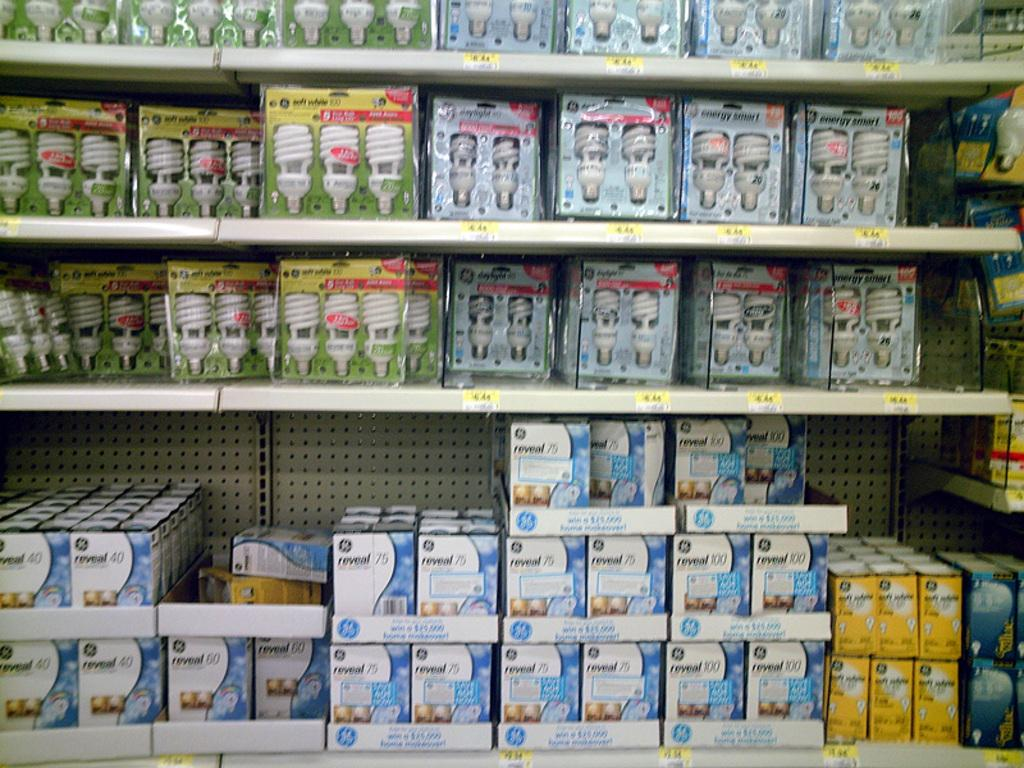What objects are present in the image? There are bulbs in the image. Where are the bulbs located? The bulbs are placed on shelves. What type of cheese is being stored on the shelves in the image? There is no cheese present in the image; it features bulbs placed on shelves. How many heads can be seen in the image? There are no heads visible in the image; it features bulbs placed on shelves. 